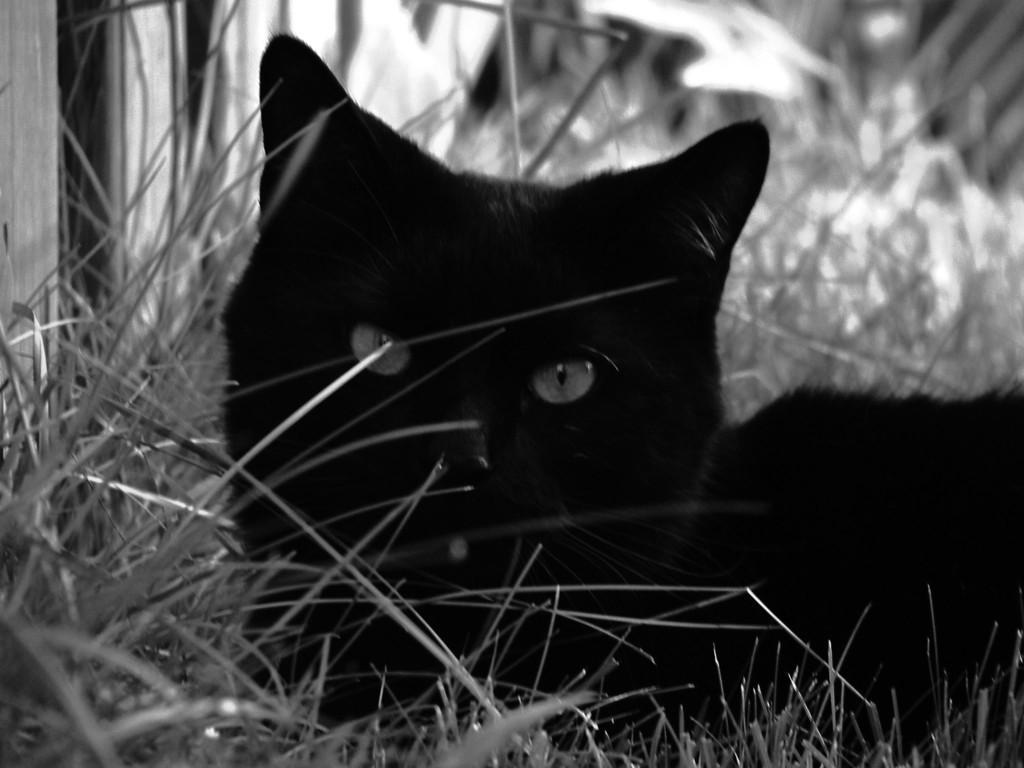Could you give a brief overview of what you see in this image? It is a black and white picture. In the center of the image we can see the grass. On the grass, we can see one cat, which is in black color. In the background there is a wooden wall, grass and a few other objects. 